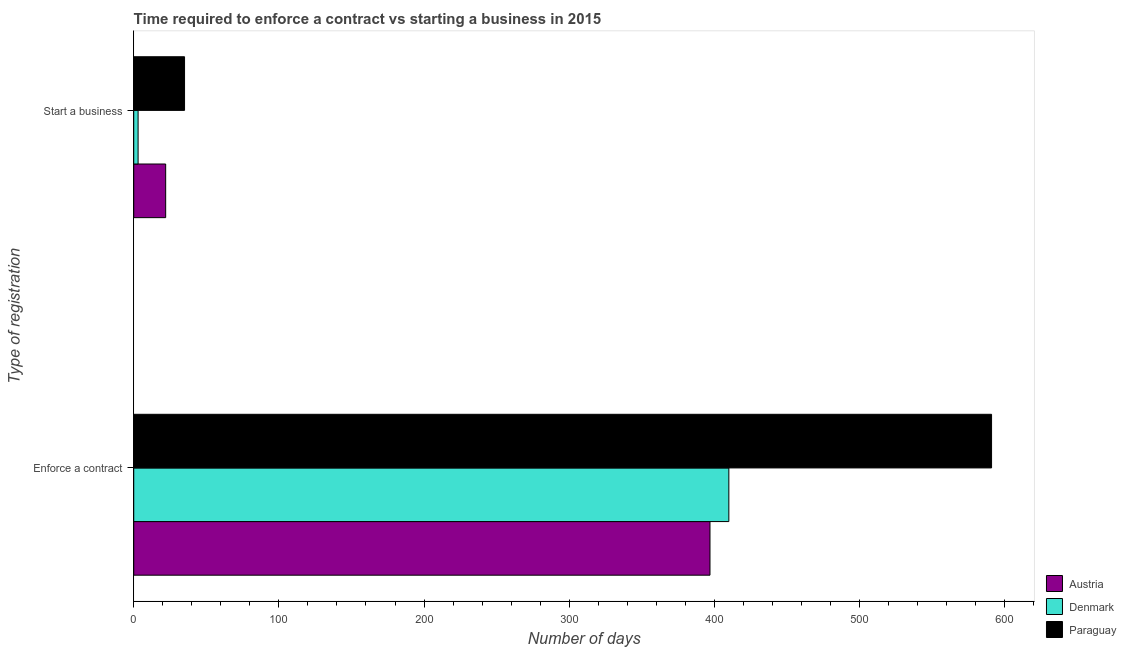How many different coloured bars are there?
Give a very brief answer. 3. How many groups of bars are there?
Make the answer very short. 2. Are the number of bars per tick equal to the number of legend labels?
Provide a succinct answer. Yes. How many bars are there on the 1st tick from the bottom?
Offer a terse response. 3. What is the label of the 2nd group of bars from the top?
Offer a terse response. Enforce a contract. What is the number of days to start a business in Denmark?
Provide a succinct answer. 3. Across all countries, what is the maximum number of days to enforece a contract?
Your answer should be compact. 591. Across all countries, what is the minimum number of days to enforece a contract?
Your response must be concise. 397. In which country was the number of days to start a business maximum?
Give a very brief answer. Paraguay. In which country was the number of days to start a business minimum?
Your answer should be compact. Denmark. What is the total number of days to start a business in the graph?
Your response must be concise. 60. What is the difference between the number of days to enforece a contract in Austria and that in Paraguay?
Provide a succinct answer. -194. What is the difference between the number of days to start a business in Denmark and the number of days to enforece a contract in Austria?
Give a very brief answer. -394. What is the difference between the number of days to start a business and number of days to enforece a contract in Paraguay?
Your answer should be very brief. -556. What is the ratio of the number of days to start a business in Paraguay to that in Denmark?
Your response must be concise. 11.67. Is the number of days to enforece a contract in Denmark less than that in Austria?
Provide a succinct answer. No. What does the 3rd bar from the top in Enforce a contract represents?
Provide a succinct answer. Austria. What does the 3rd bar from the bottom in Enforce a contract represents?
Offer a terse response. Paraguay. How many bars are there?
Give a very brief answer. 6. Does the graph contain any zero values?
Your response must be concise. No. Where does the legend appear in the graph?
Offer a terse response. Bottom right. What is the title of the graph?
Offer a very short reply. Time required to enforce a contract vs starting a business in 2015. Does "Solomon Islands" appear as one of the legend labels in the graph?
Give a very brief answer. No. What is the label or title of the X-axis?
Keep it short and to the point. Number of days. What is the label or title of the Y-axis?
Your response must be concise. Type of registration. What is the Number of days of Austria in Enforce a contract?
Provide a short and direct response. 397. What is the Number of days in Denmark in Enforce a contract?
Your response must be concise. 410. What is the Number of days in Paraguay in Enforce a contract?
Make the answer very short. 591. What is the Number of days in Denmark in Start a business?
Your response must be concise. 3. Across all Type of registration, what is the maximum Number of days of Austria?
Offer a terse response. 397. Across all Type of registration, what is the maximum Number of days in Denmark?
Give a very brief answer. 410. Across all Type of registration, what is the maximum Number of days of Paraguay?
Provide a short and direct response. 591. What is the total Number of days of Austria in the graph?
Give a very brief answer. 419. What is the total Number of days of Denmark in the graph?
Offer a terse response. 413. What is the total Number of days of Paraguay in the graph?
Your answer should be very brief. 626. What is the difference between the Number of days in Austria in Enforce a contract and that in Start a business?
Keep it short and to the point. 375. What is the difference between the Number of days in Denmark in Enforce a contract and that in Start a business?
Make the answer very short. 407. What is the difference between the Number of days of Paraguay in Enforce a contract and that in Start a business?
Give a very brief answer. 556. What is the difference between the Number of days in Austria in Enforce a contract and the Number of days in Denmark in Start a business?
Offer a very short reply. 394. What is the difference between the Number of days of Austria in Enforce a contract and the Number of days of Paraguay in Start a business?
Offer a very short reply. 362. What is the difference between the Number of days of Denmark in Enforce a contract and the Number of days of Paraguay in Start a business?
Your response must be concise. 375. What is the average Number of days in Austria per Type of registration?
Keep it short and to the point. 209.5. What is the average Number of days in Denmark per Type of registration?
Your answer should be compact. 206.5. What is the average Number of days in Paraguay per Type of registration?
Ensure brevity in your answer.  313. What is the difference between the Number of days in Austria and Number of days in Denmark in Enforce a contract?
Offer a very short reply. -13. What is the difference between the Number of days in Austria and Number of days in Paraguay in Enforce a contract?
Provide a short and direct response. -194. What is the difference between the Number of days in Denmark and Number of days in Paraguay in Enforce a contract?
Your answer should be compact. -181. What is the difference between the Number of days in Denmark and Number of days in Paraguay in Start a business?
Your response must be concise. -32. What is the ratio of the Number of days in Austria in Enforce a contract to that in Start a business?
Your answer should be very brief. 18.05. What is the ratio of the Number of days of Denmark in Enforce a contract to that in Start a business?
Provide a succinct answer. 136.67. What is the ratio of the Number of days in Paraguay in Enforce a contract to that in Start a business?
Provide a succinct answer. 16.89. What is the difference between the highest and the second highest Number of days of Austria?
Your answer should be compact. 375. What is the difference between the highest and the second highest Number of days of Denmark?
Provide a short and direct response. 407. What is the difference between the highest and the second highest Number of days of Paraguay?
Provide a succinct answer. 556. What is the difference between the highest and the lowest Number of days in Austria?
Your response must be concise. 375. What is the difference between the highest and the lowest Number of days of Denmark?
Your answer should be very brief. 407. What is the difference between the highest and the lowest Number of days in Paraguay?
Make the answer very short. 556. 